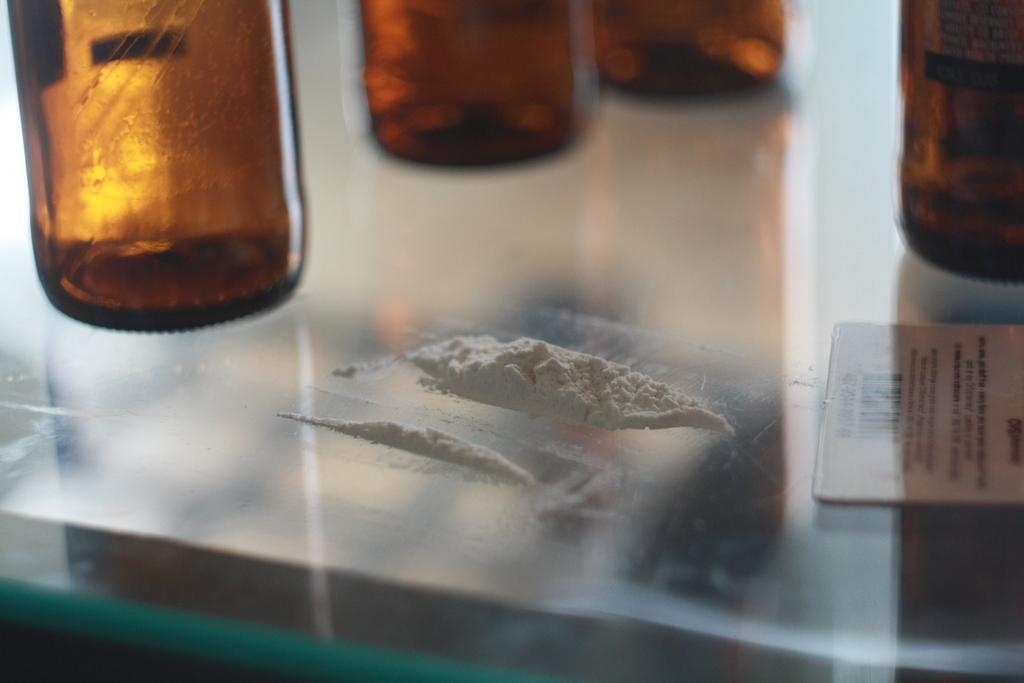Describe this image in one or two sentences. In this picture there are four brown glass bottles placed on a glass table and to the left side there is powder which is white in color. There is a label beside it on which information is printed. 